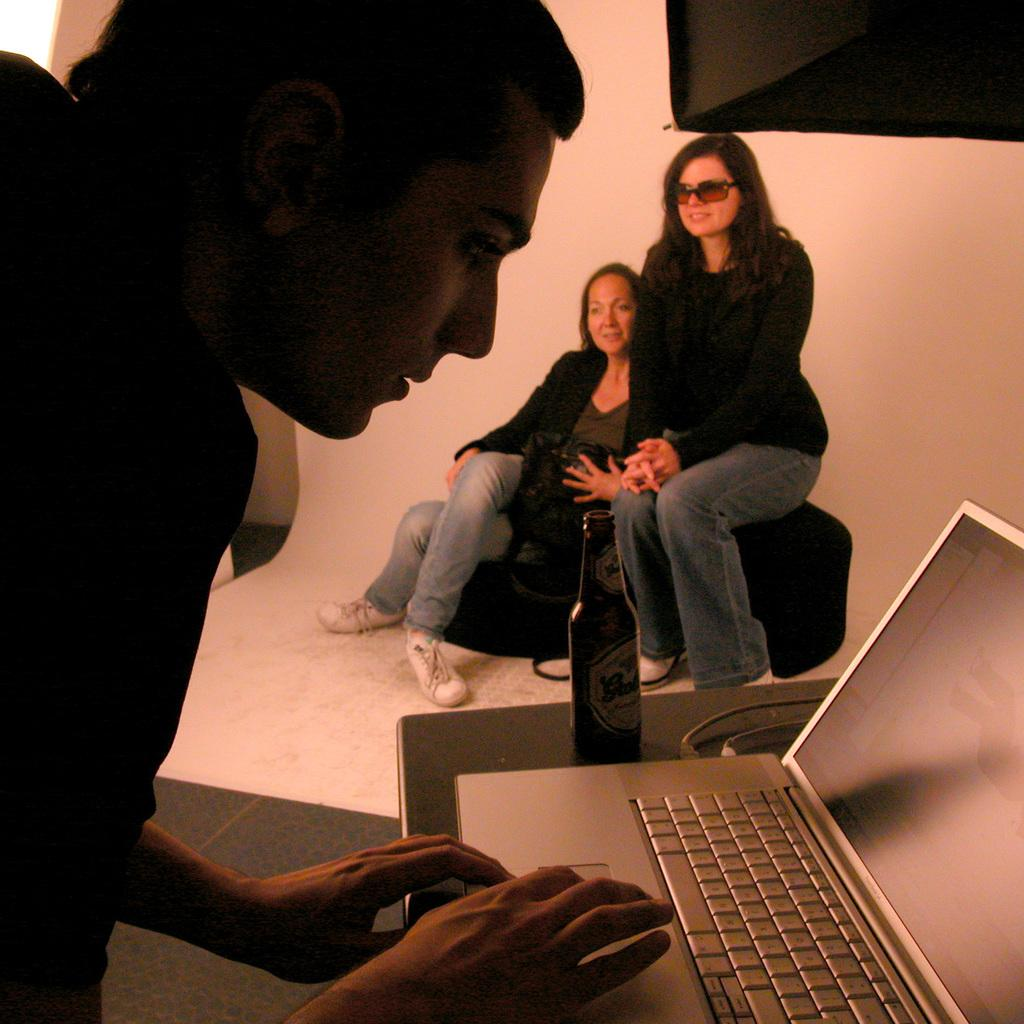How many people are in the image? There are two persons in the image. What are the persons wearing? The persons are wearing clothes. What are the persons doing in the image? The persons are sitting on a seat. Can you describe the activity of the person on the left side of the image? The person on the left side of the image is using a laptop. What object can be seen on the table in the image? There is a bottle on the table. What is the size of the reaction caused by the apparatus in the image? There is no apparatus present in the image, and therefore no reaction can be observed. 